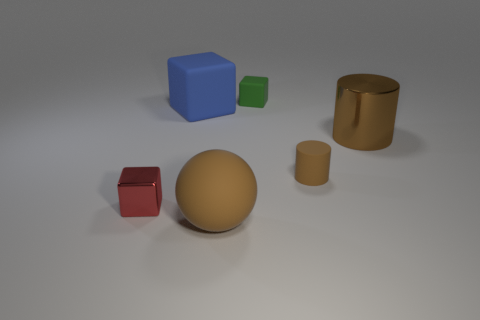Does the small red thing have the same shape as the green thing?
Offer a very short reply. Yes. Is there anything else that is the same color as the big block?
Keep it short and to the point. No. The other tiny metal object that is the same shape as the blue object is what color?
Offer a very short reply. Red. Is the number of small red shiny objects on the right side of the green matte object greater than the number of brown objects?
Provide a short and direct response. No. There is a matte object that is on the left side of the big brown matte thing; what color is it?
Provide a short and direct response. Blue. Is the size of the green matte cube the same as the blue matte cube?
Your answer should be very brief. No. The green matte object has what size?
Offer a terse response. Small. The small matte object that is the same color as the large metallic cylinder is what shape?
Ensure brevity in your answer.  Cylinder. Are there more blocks than brown matte cylinders?
Give a very brief answer. Yes. There is a large rubber object in front of the big thing that is left of the big object that is in front of the tiny red metal cube; what is its color?
Offer a very short reply. Brown. 